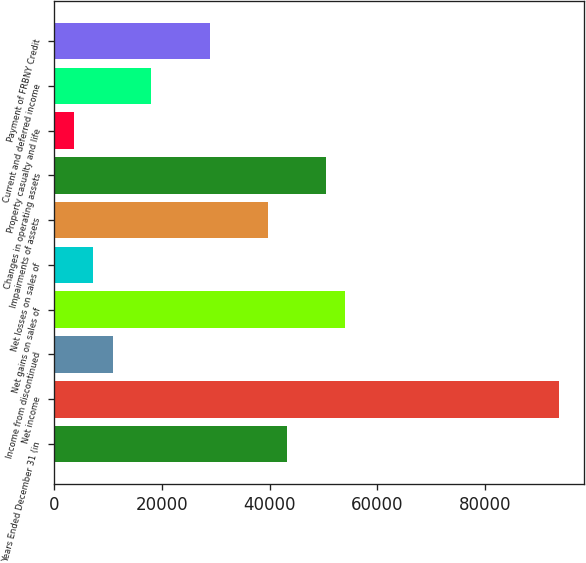<chart> <loc_0><loc_0><loc_500><loc_500><bar_chart><fcel>Years Ended December 31 (in<fcel>Net income<fcel>Income from discontinued<fcel>Net gains on sales of<fcel>Net losses on sales of<fcel>Impairments of assets<fcel>Changes in operating assets<fcel>Property casualty and life<fcel>Current and deferred income<fcel>Payment of FRBNY Credit<nl><fcel>43255.2<fcel>93691.6<fcel>10831.8<fcel>54063<fcel>7229.2<fcel>39652.6<fcel>50460.4<fcel>3626.6<fcel>18037<fcel>28844.8<nl></chart> 